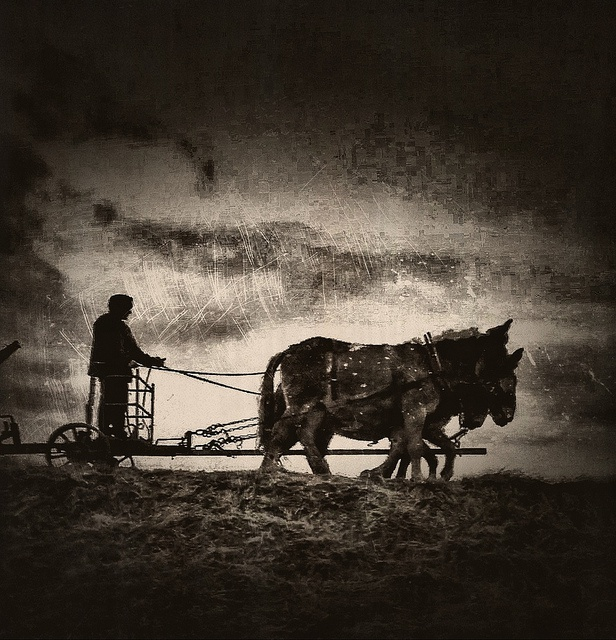Describe the objects in this image and their specific colors. I can see horse in black and gray tones, people in black, gray, and darkgray tones, horse in black, darkgray, and gray tones, and horse in black, gray, and darkgray tones in this image. 